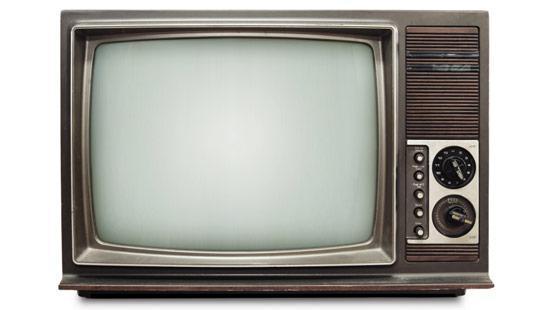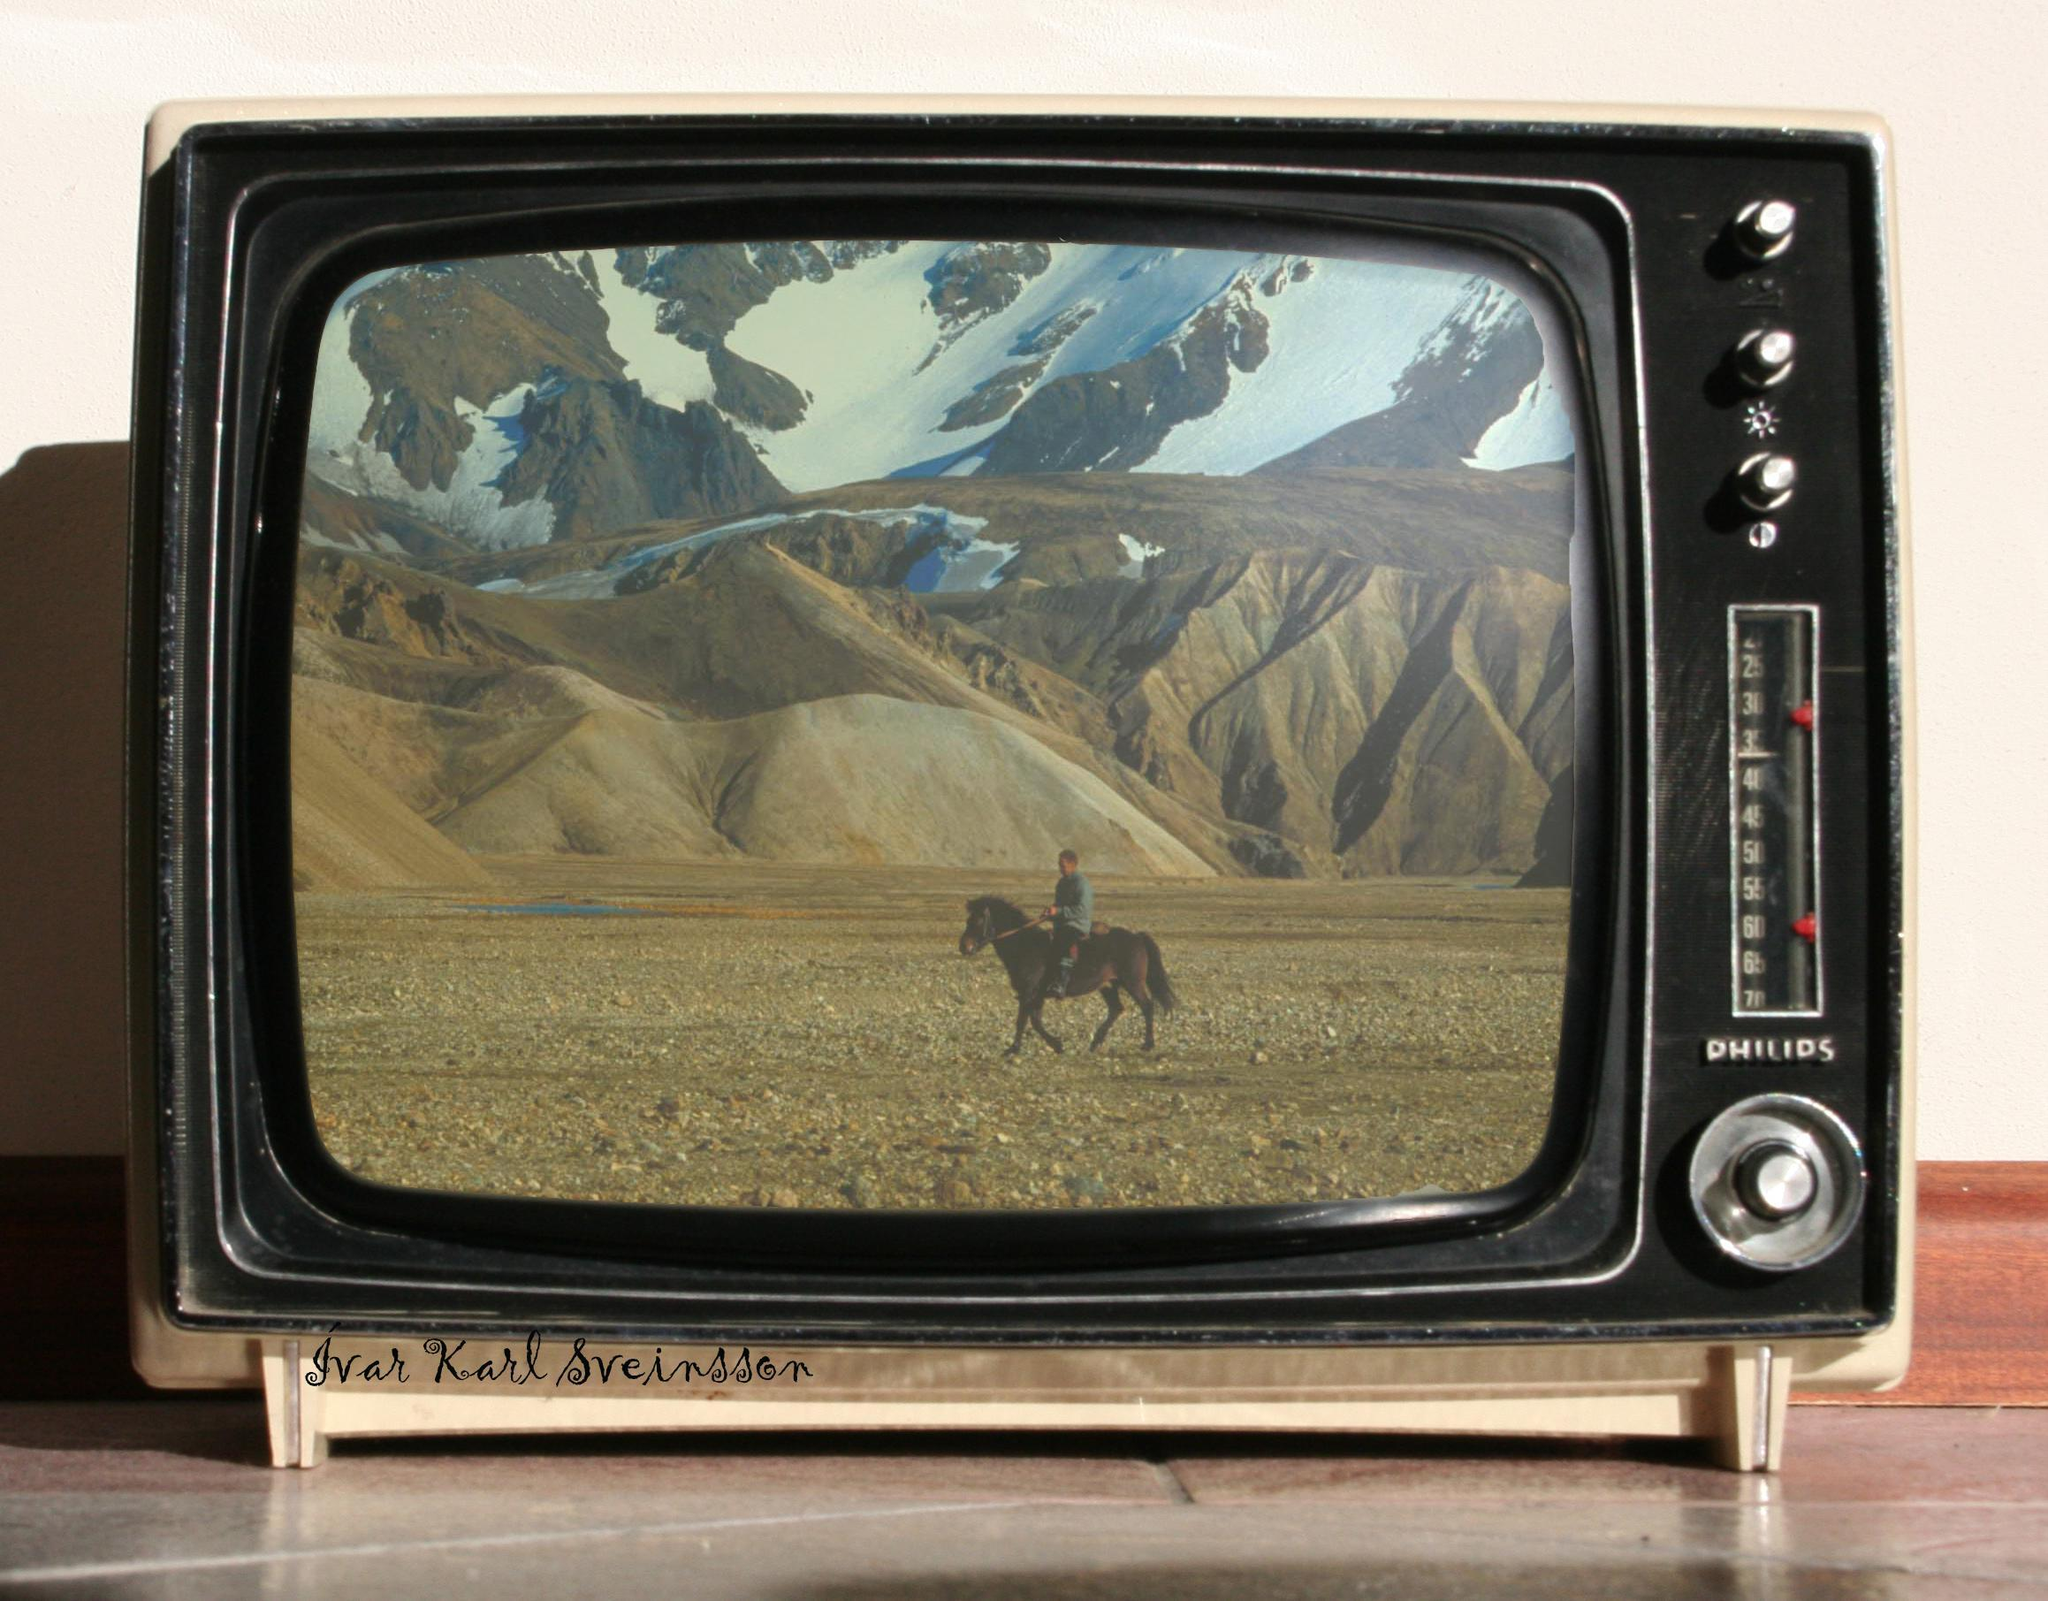The first image is the image on the left, the second image is the image on the right. For the images displayed, is the sentence "One of the two televisions is showing an image." factually correct? Answer yes or no. Yes. The first image is the image on the left, the second image is the image on the right. For the images displayed, is the sentence "Each image contains a single old-fashioned TV in the foreground, and in one image the TV has a picture on the screen." factually correct? Answer yes or no. Yes. 